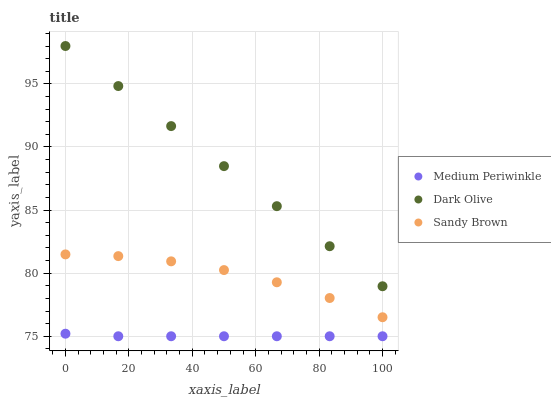Does Medium Periwinkle have the minimum area under the curve?
Answer yes or no. Yes. Does Dark Olive have the maximum area under the curve?
Answer yes or no. Yes. Does Dark Olive have the minimum area under the curve?
Answer yes or no. No. Does Medium Periwinkle have the maximum area under the curve?
Answer yes or no. No. Is Dark Olive the smoothest?
Answer yes or no. Yes. Is Sandy Brown the roughest?
Answer yes or no. Yes. Is Medium Periwinkle the smoothest?
Answer yes or no. No. Is Medium Periwinkle the roughest?
Answer yes or no. No. Does Medium Periwinkle have the lowest value?
Answer yes or no. Yes. Does Dark Olive have the lowest value?
Answer yes or no. No. Does Dark Olive have the highest value?
Answer yes or no. Yes. Does Medium Periwinkle have the highest value?
Answer yes or no. No. Is Medium Periwinkle less than Dark Olive?
Answer yes or no. Yes. Is Sandy Brown greater than Medium Periwinkle?
Answer yes or no. Yes. Does Medium Periwinkle intersect Dark Olive?
Answer yes or no. No. 